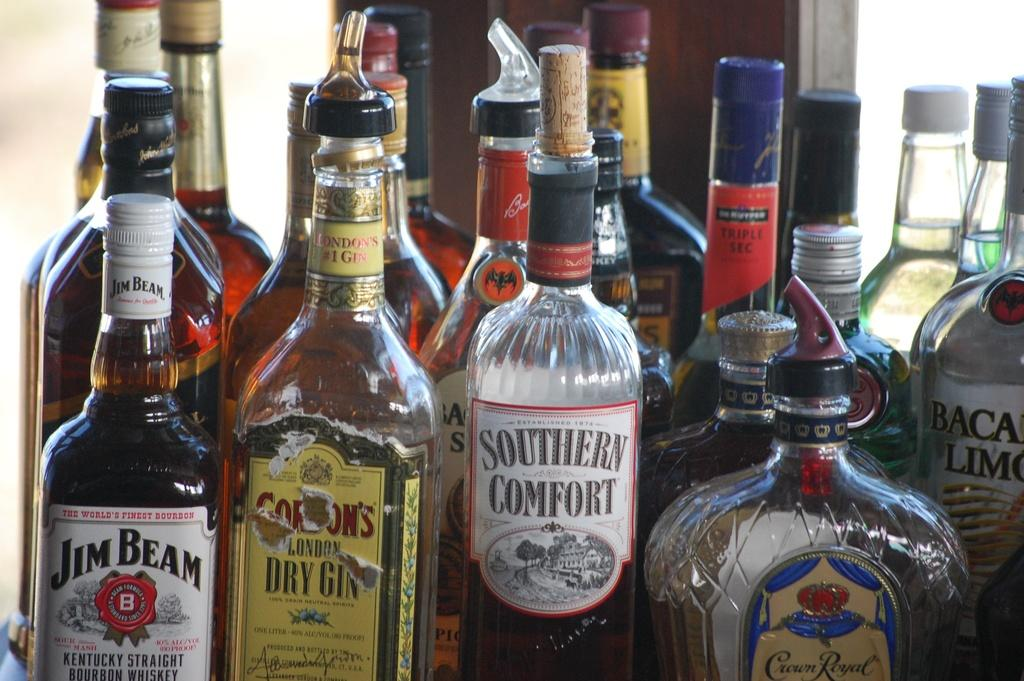Provide a one-sentence caption for the provided image. Jim Bean Crown Royal and various other whiskey beverages sitting in a corner. 